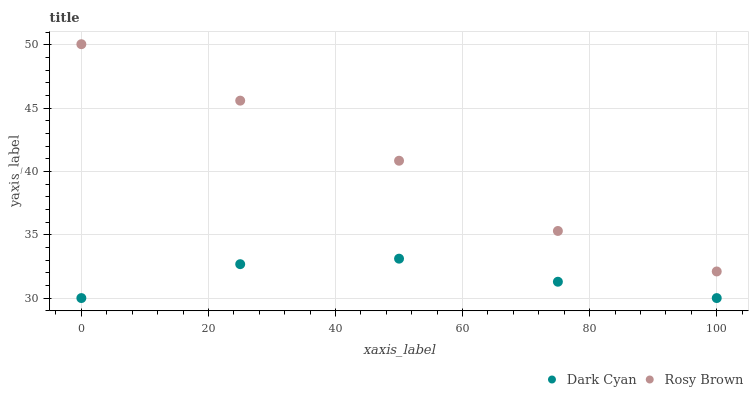Does Dark Cyan have the minimum area under the curve?
Answer yes or no. Yes. Does Rosy Brown have the maximum area under the curve?
Answer yes or no. Yes. Does Rosy Brown have the minimum area under the curve?
Answer yes or no. No. Is Rosy Brown the smoothest?
Answer yes or no. Yes. Is Dark Cyan the roughest?
Answer yes or no. Yes. Is Rosy Brown the roughest?
Answer yes or no. No. Does Dark Cyan have the lowest value?
Answer yes or no. Yes. Does Rosy Brown have the lowest value?
Answer yes or no. No. Does Rosy Brown have the highest value?
Answer yes or no. Yes. Is Dark Cyan less than Rosy Brown?
Answer yes or no. Yes. Is Rosy Brown greater than Dark Cyan?
Answer yes or no. Yes. Does Dark Cyan intersect Rosy Brown?
Answer yes or no. No. 